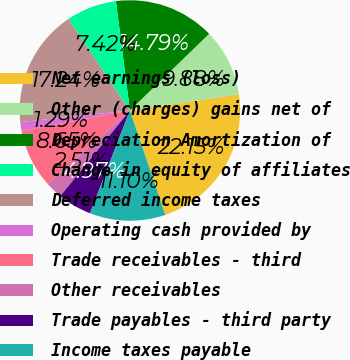<chart> <loc_0><loc_0><loc_500><loc_500><pie_chart><fcel>Net earnings (loss)<fcel>Other (charges) gains net of<fcel>Depreciation Amortization of<fcel>Change in equity of affiliates<fcel>Deferred income taxes<fcel>Operating cash provided by<fcel>Trade receivables - third<fcel>Other receivables<fcel>Trade payables - third party<fcel>Income taxes payable<nl><fcel>22.15%<fcel>9.88%<fcel>14.79%<fcel>7.42%<fcel>17.24%<fcel>1.29%<fcel>8.65%<fcel>2.51%<fcel>4.97%<fcel>11.1%<nl></chart> 